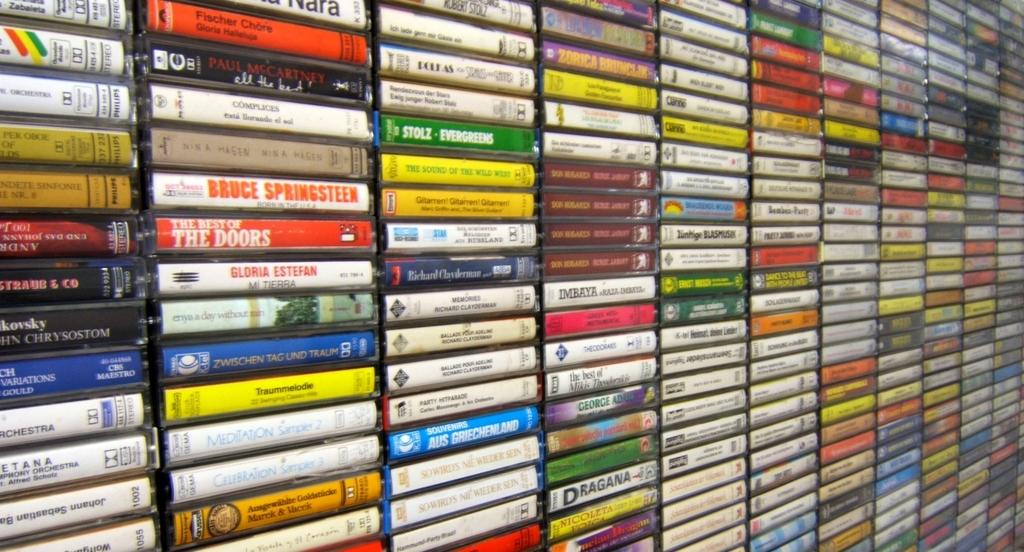<image>
Render a clear and concise summary of the photo. A couple of the videos feature Bruce Springstein and The Doors. 